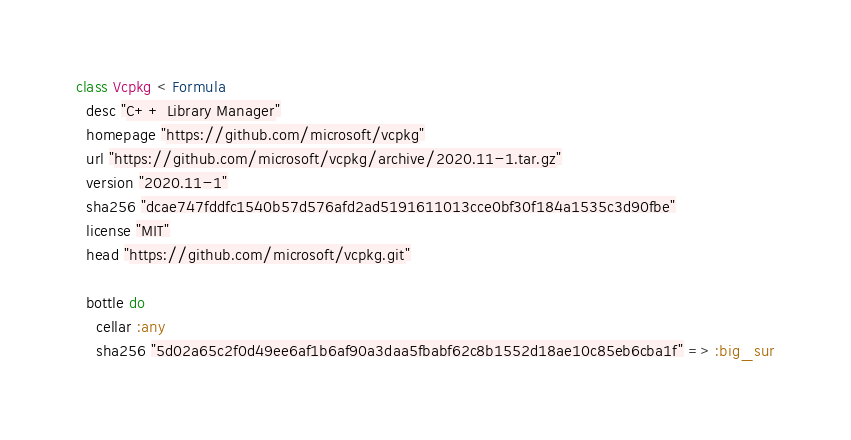Convert code to text. <code><loc_0><loc_0><loc_500><loc_500><_Ruby_>class Vcpkg < Formula
  desc "C++ Library Manager"
  homepage "https://github.com/microsoft/vcpkg"
  url "https://github.com/microsoft/vcpkg/archive/2020.11-1.tar.gz"
  version "2020.11-1"
  sha256 "dcae747fddfc1540b57d576afd2ad5191611013cce0bf30f184a1535c3d90fbe"
  license "MIT"
  head "https://github.com/microsoft/vcpkg.git"

  bottle do
    cellar :any
    sha256 "5d02a65c2f0d49ee6af1b6af90a3daa5fbabf62c8b1552d18ae10c85eb6cba1f" => :big_sur</code> 